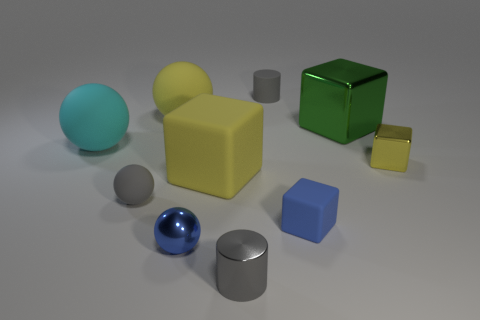There is a shiny thing that is on the right side of the tiny blue metal object and on the left side of the green metallic block; what is its color? The small object located to the right of the tiny blue metal sphere and to the left of the green metallic cube appears to be silver or chrome in color. This reflective property suggests that the object is likely made of metal, which tends to have a shiny surface. 